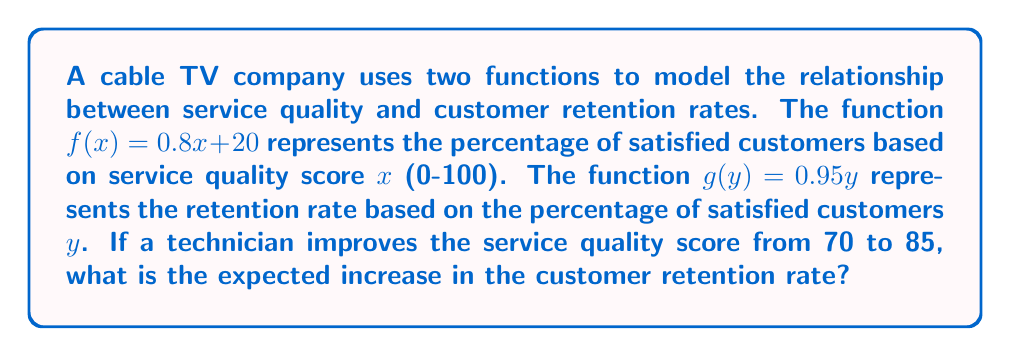What is the answer to this math problem? To solve this problem, we need to compose the functions $f$ and $g$ and calculate the difference in retention rates for the two service quality scores.

Step 1: Compose the functions $g(f(x))$
$g(f(x)) = g(0.8x + 20) = 0.95(0.8x + 20) = 0.76x + 19$

Step 2: Calculate the retention rate for the initial service quality score (70)
$g(f(70)) = 0.76(70) + 19 = 53.2 + 19 = 72.2\%$

Step 3: Calculate the retention rate for the improved service quality score (85)
$g(f(85)) = 0.76(85) + 19 = 64.6 + 19 = 83.6\%$

Step 4: Calculate the difference in retention rates
$83.6\% - 72.2\% = 11.4\%$

Therefore, the expected increase in the customer retention rate is 11.4%.
Answer: 11.4% 